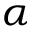<formula> <loc_0><loc_0><loc_500><loc_500>\alpha</formula> 